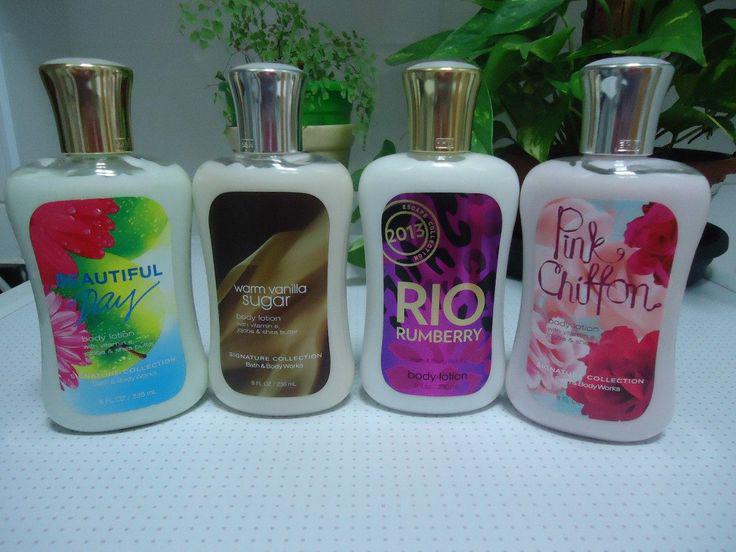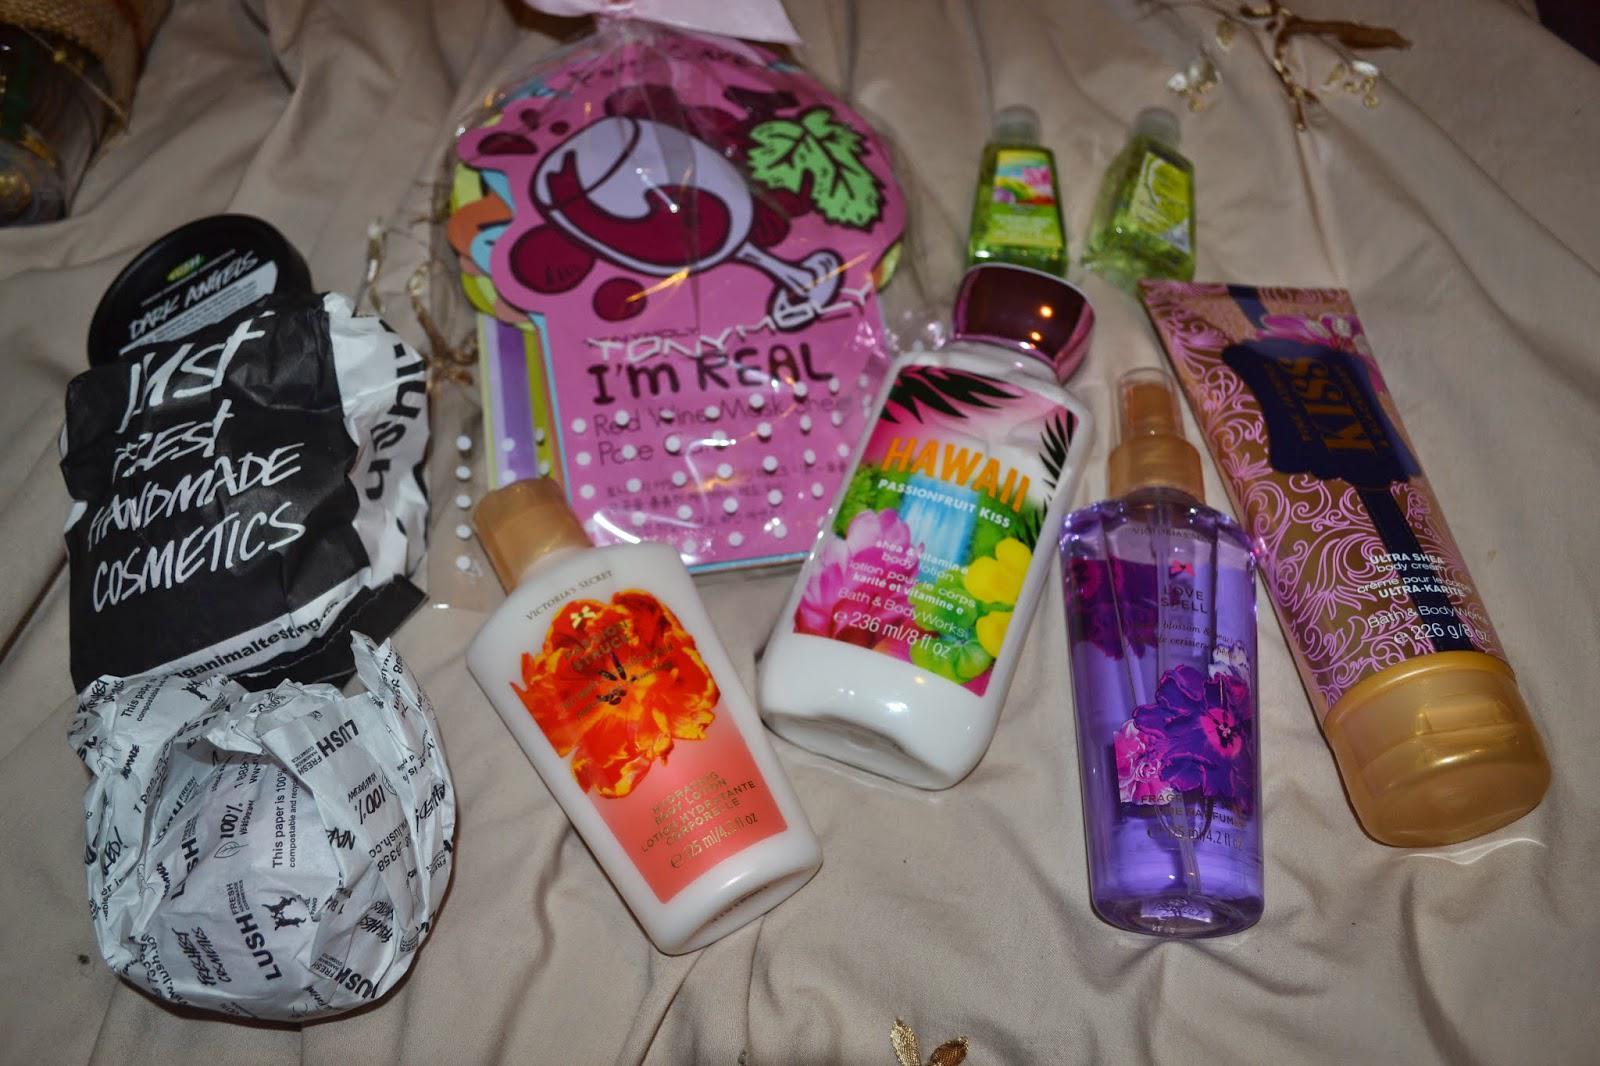The first image is the image on the left, the second image is the image on the right. Given the left and right images, does the statement "There are five lotions/fragrances in total." hold true? Answer yes or no. No. The first image is the image on the left, the second image is the image on the right. Analyze the images presented: Is the assertion "The images contain no more than three beauty products." valid? Answer yes or no. No. 